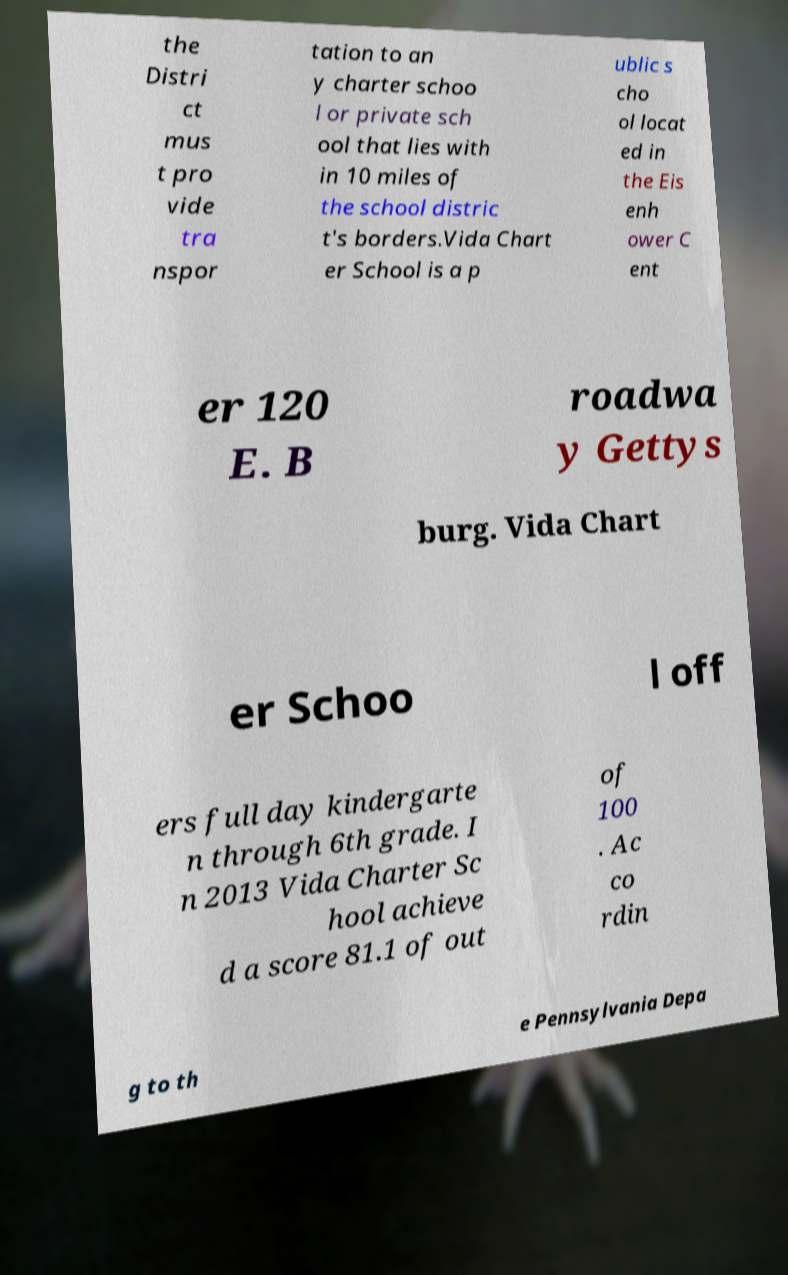Could you extract and type out the text from this image? the Distri ct mus t pro vide tra nspor tation to an y charter schoo l or private sch ool that lies with in 10 miles of the school distric t's borders.Vida Chart er School is a p ublic s cho ol locat ed in the Eis enh ower C ent er 120 E. B roadwa y Gettys burg. Vida Chart er Schoo l off ers full day kindergarte n through 6th grade. I n 2013 Vida Charter Sc hool achieve d a score 81.1 of out of 100 . Ac co rdin g to th e Pennsylvania Depa 